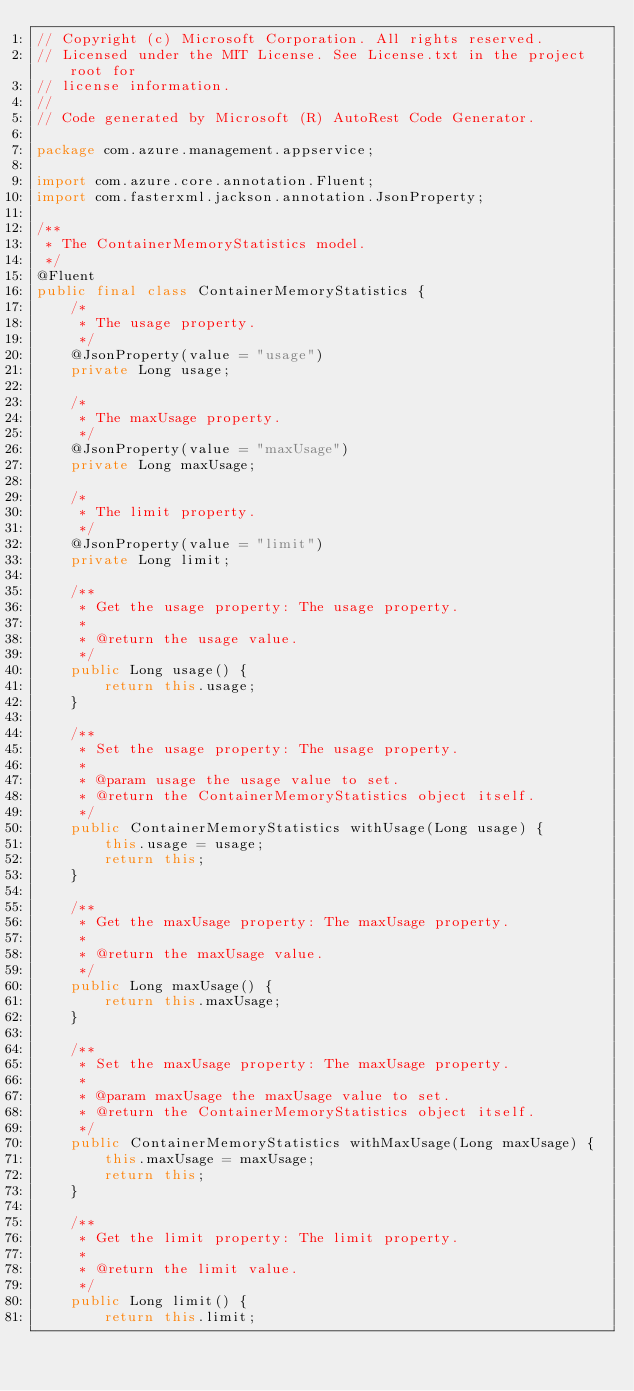Convert code to text. <code><loc_0><loc_0><loc_500><loc_500><_Java_>// Copyright (c) Microsoft Corporation. All rights reserved.
// Licensed under the MIT License. See License.txt in the project root for
// license information.
// 
// Code generated by Microsoft (R) AutoRest Code Generator.

package com.azure.management.appservice;

import com.azure.core.annotation.Fluent;
import com.fasterxml.jackson.annotation.JsonProperty;

/**
 * The ContainerMemoryStatistics model.
 */
@Fluent
public final class ContainerMemoryStatistics {
    /*
     * The usage property.
     */
    @JsonProperty(value = "usage")
    private Long usage;

    /*
     * The maxUsage property.
     */
    @JsonProperty(value = "maxUsage")
    private Long maxUsage;

    /*
     * The limit property.
     */
    @JsonProperty(value = "limit")
    private Long limit;

    /**
     * Get the usage property: The usage property.
     * 
     * @return the usage value.
     */
    public Long usage() {
        return this.usage;
    }

    /**
     * Set the usage property: The usage property.
     * 
     * @param usage the usage value to set.
     * @return the ContainerMemoryStatistics object itself.
     */
    public ContainerMemoryStatistics withUsage(Long usage) {
        this.usage = usage;
        return this;
    }

    /**
     * Get the maxUsage property: The maxUsage property.
     * 
     * @return the maxUsage value.
     */
    public Long maxUsage() {
        return this.maxUsage;
    }

    /**
     * Set the maxUsage property: The maxUsage property.
     * 
     * @param maxUsage the maxUsage value to set.
     * @return the ContainerMemoryStatistics object itself.
     */
    public ContainerMemoryStatistics withMaxUsage(Long maxUsage) {
        this.maxUsage = maxUsage;
        return this;
    }

    /**
     * Get the limit property: The limit property.
     * 
     * @return the limit value.
     */
    public Long limit() {
        return this.limit;</code> 